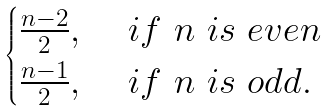Convert formula to latex. <formula><loc_0><loc_0><loc_500><loc_500>\begin{cases} { \frac { n - 2 } { 2 } } , & \ i f \ n \ i s \ e v e n \\ { \frac { n - 1 } { 2 } } , & \ i f \ n \ i s \ o d d . \end{cases}</formula> 